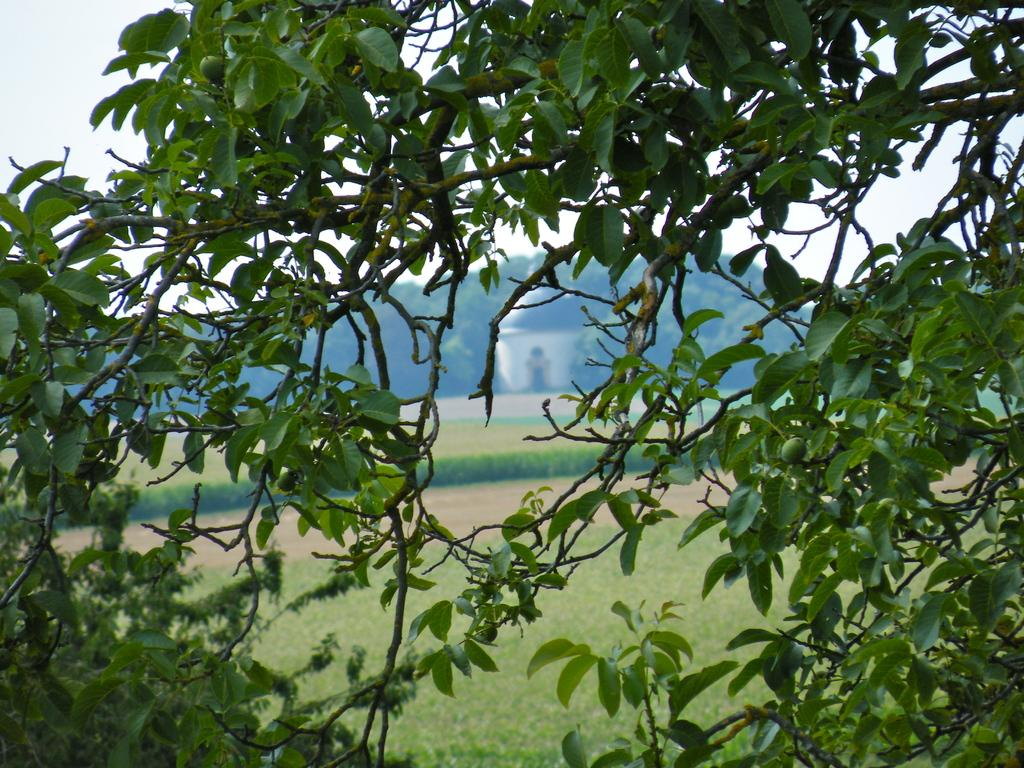What type of vegetation can be seen in the image? There are trees in the image. What can be seen in the distance behind the trees? There are hills visible in the background of the image. What is the ground covered with in the background? There is grass in the background of the image. Is there a path visible in the image? Yes, there is a path in the background of the image. What structure is present in the image? There is a dome with an entry in the image. What is visible above the hills in the image? The sky is visible above the hills. Where is the desk located in the image? There is no desk present in the image. Is there a band playing music in the image? There is no band present in the image. 